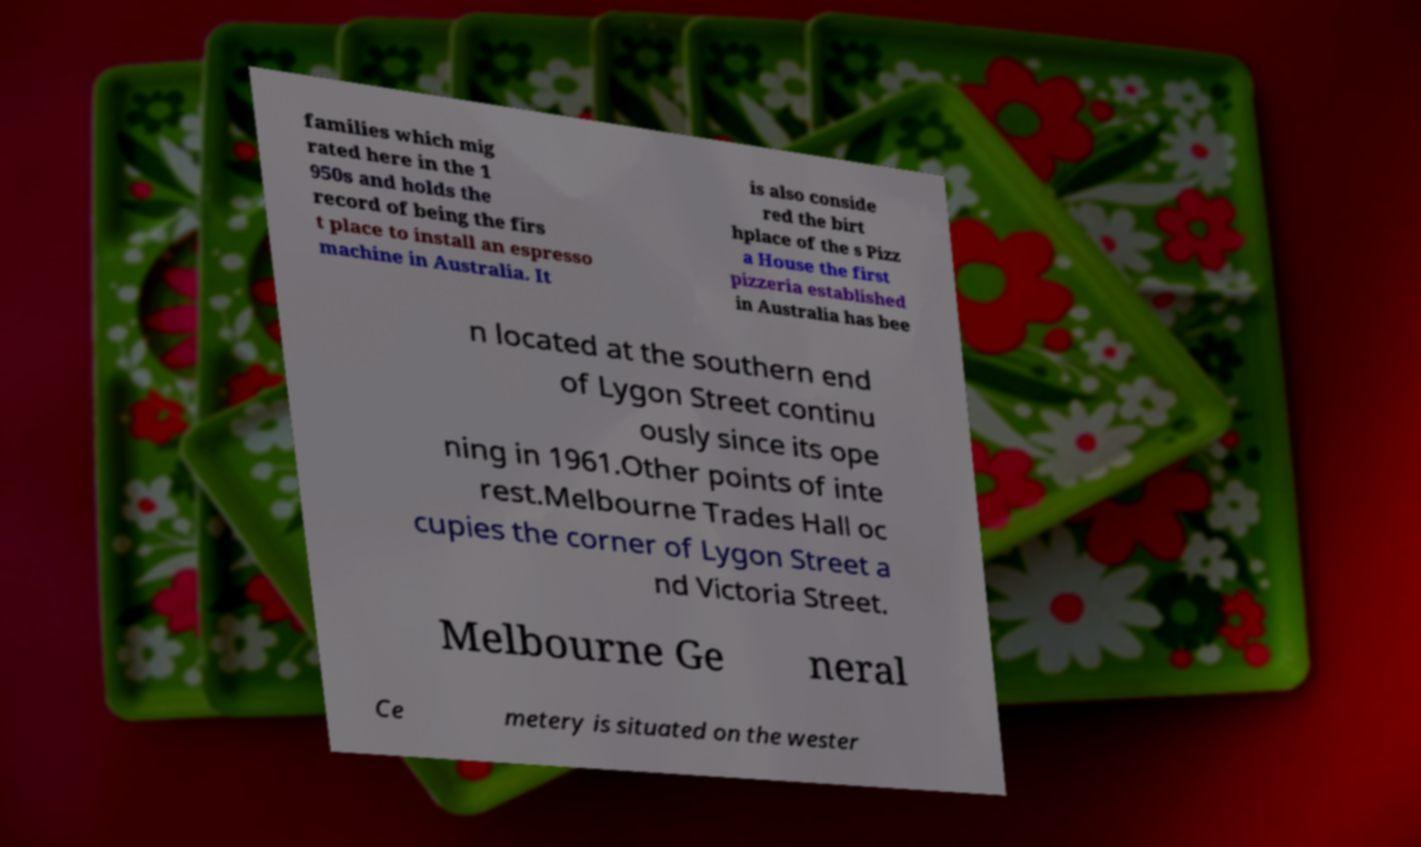Please read and relay the text visible in this image. What does it say? families which mig rated here in the 1 950s and holds the record of being the firs t place to install an espresso machine in Australia. It is also conside red the birt hplace of the s Pizz a House the first pizzeria established in Australia has bee n located at the southern end of Lygon Street continu ously since its ope ning in 1961.Other points of inte rest.Melbourne Trades Hall oc cupies the corner of Lygon Street a nd Victoria Street. Melbourne Ge neral Ce metery is situated on the wester 